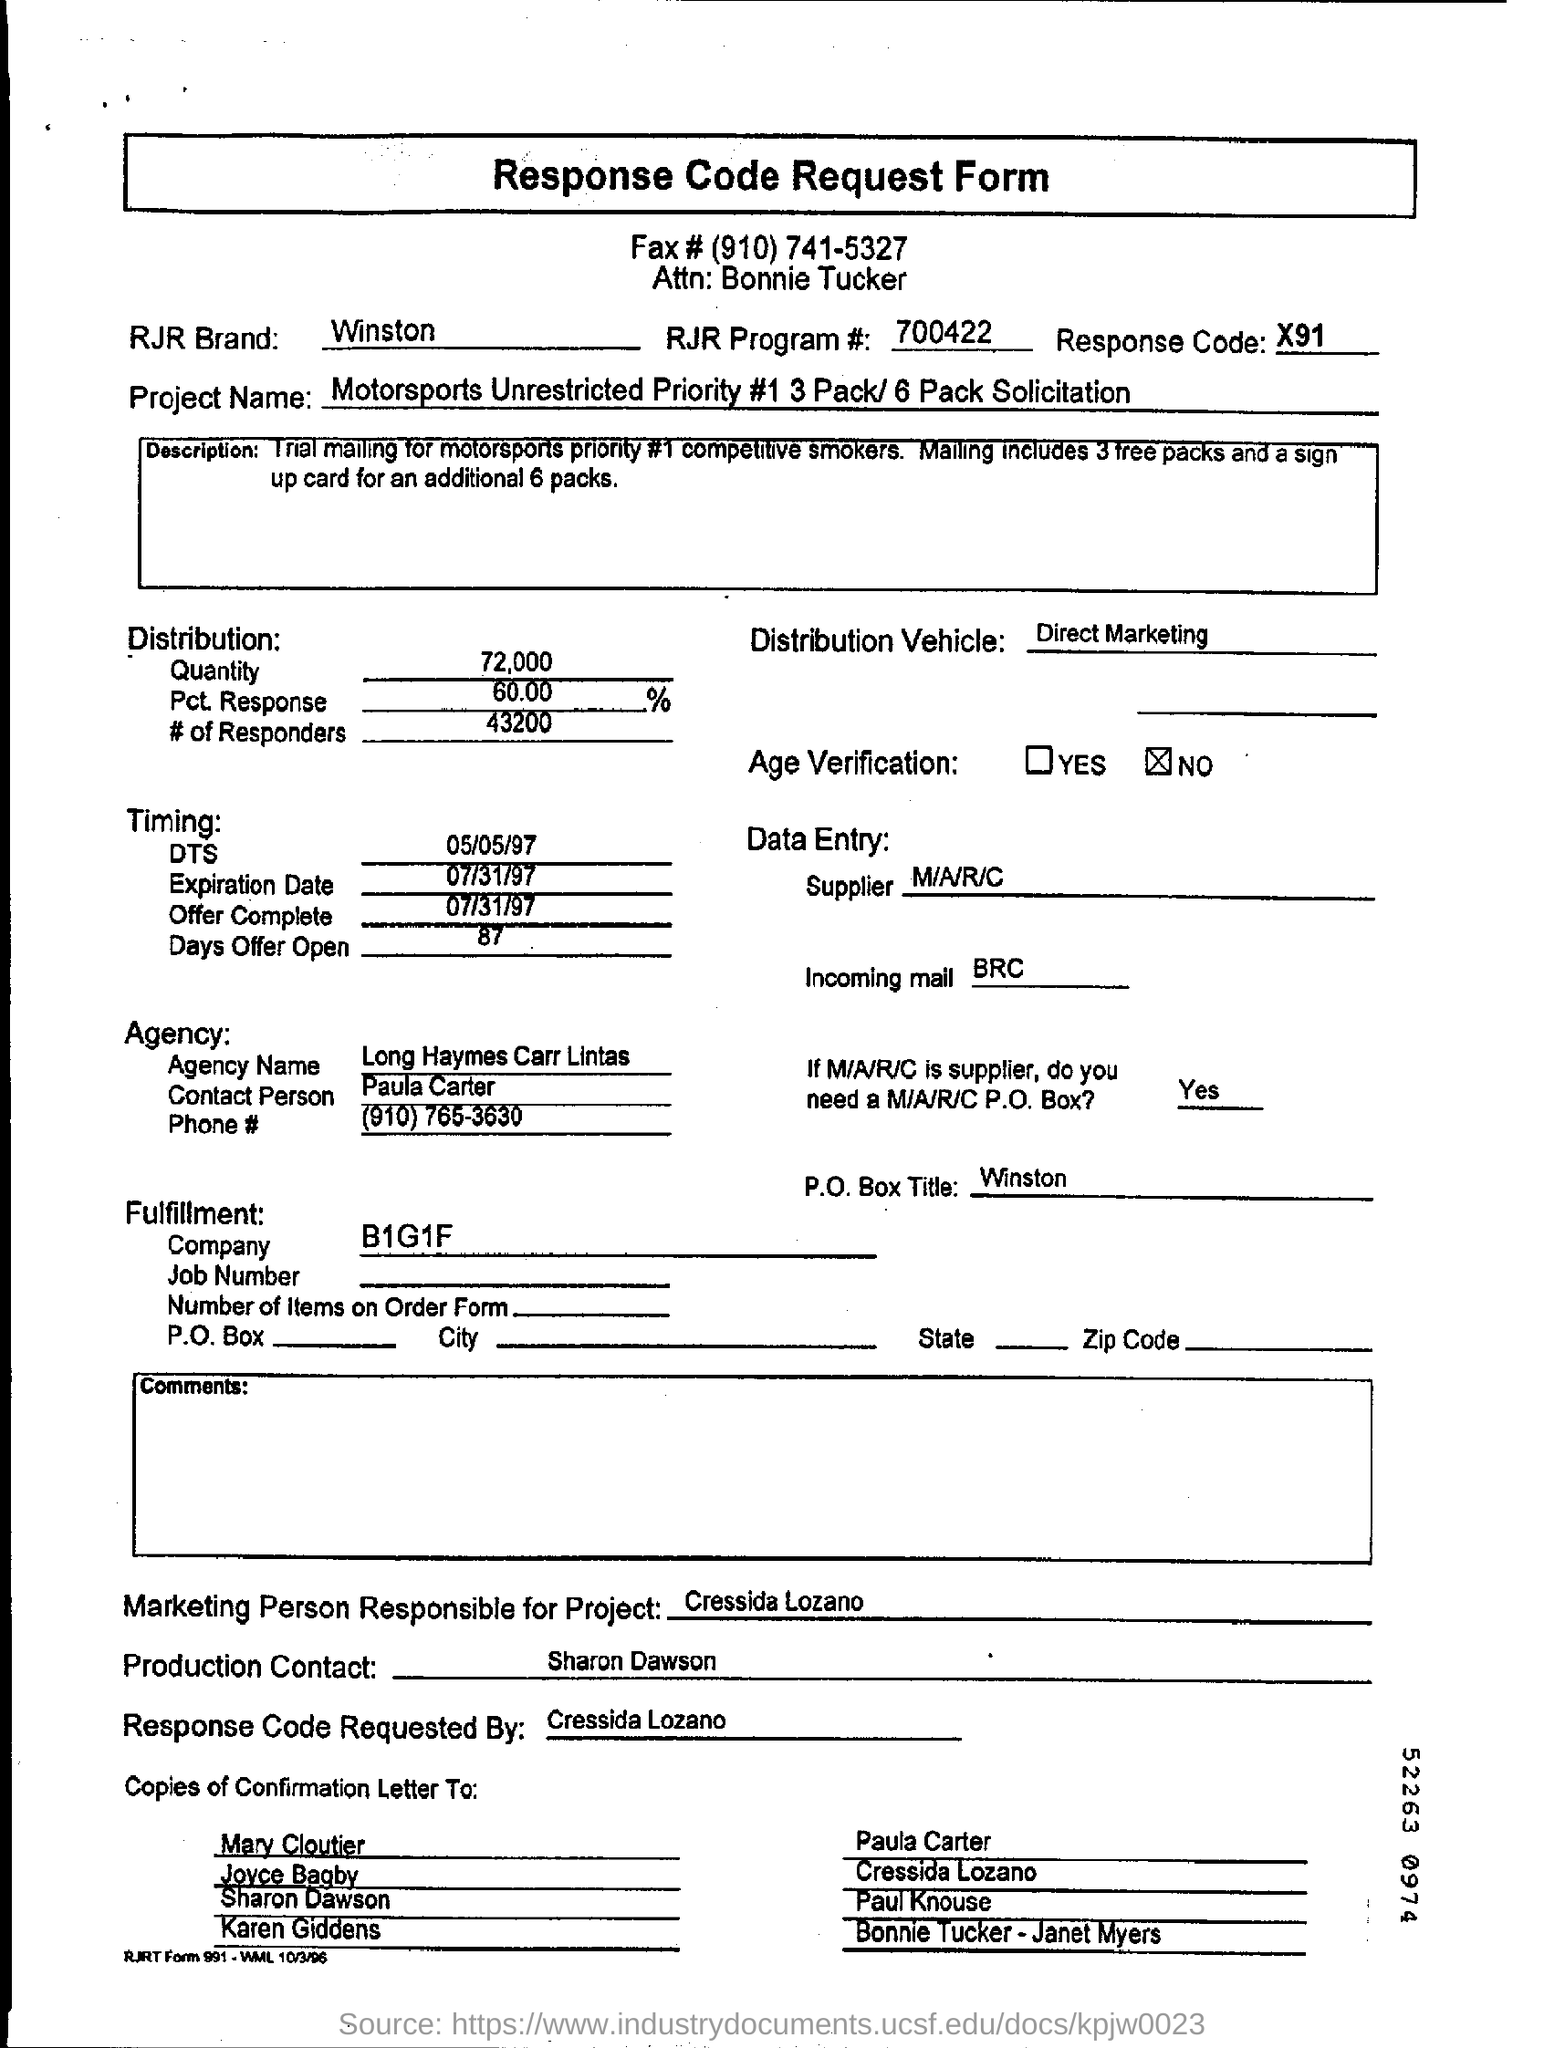What does the 'Quantity' figure represent? The 'Quantity' figure notes the total number of units, which in this case is 72,000. This indicates the scale of the direct marketing campaign and how many potential customers they intended to reach with this solicitation. And what does the 'Pct. Response' indicate? The 'Pct. Response' likely represents the percentage of the total quantity from which a response is expected or received. Here, it's shown as 60.00%, with '# of Responders' being 43,200, calculated from the total quantity distributed. 